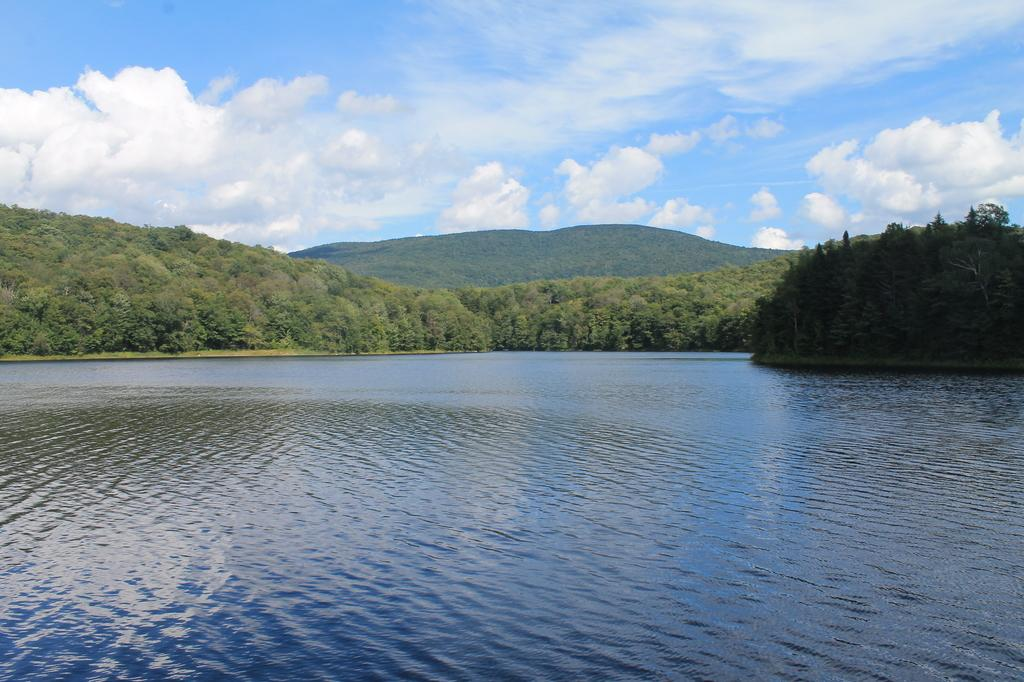What type of landscape is depicted in the image? The image features hills and trees, indicating a natural landscape. What can be seen in the sky in the image? The sky is visible in the image, and clouds are present. What is visible at the bottom of the image? There is water visible at the bottom of the image. Where is the turkey located in the image? There is no turkey present in the image. What is the father doing in the image? There is no reference to a father or any human figures in the image. 